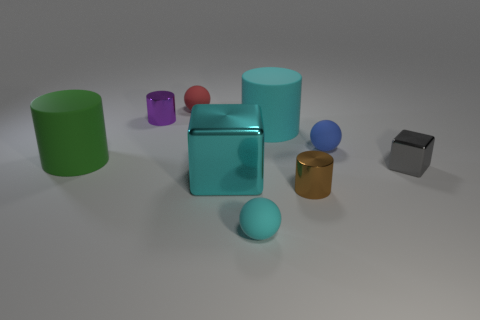There is a purple object that is the same material as the large cyan cube; what is its shape? The purple object sharing the same material characteristics as the large cyan cube is a cylinder. It has a circular base and appears smooth and reflective, similar to the cyan cube's surface finish. 